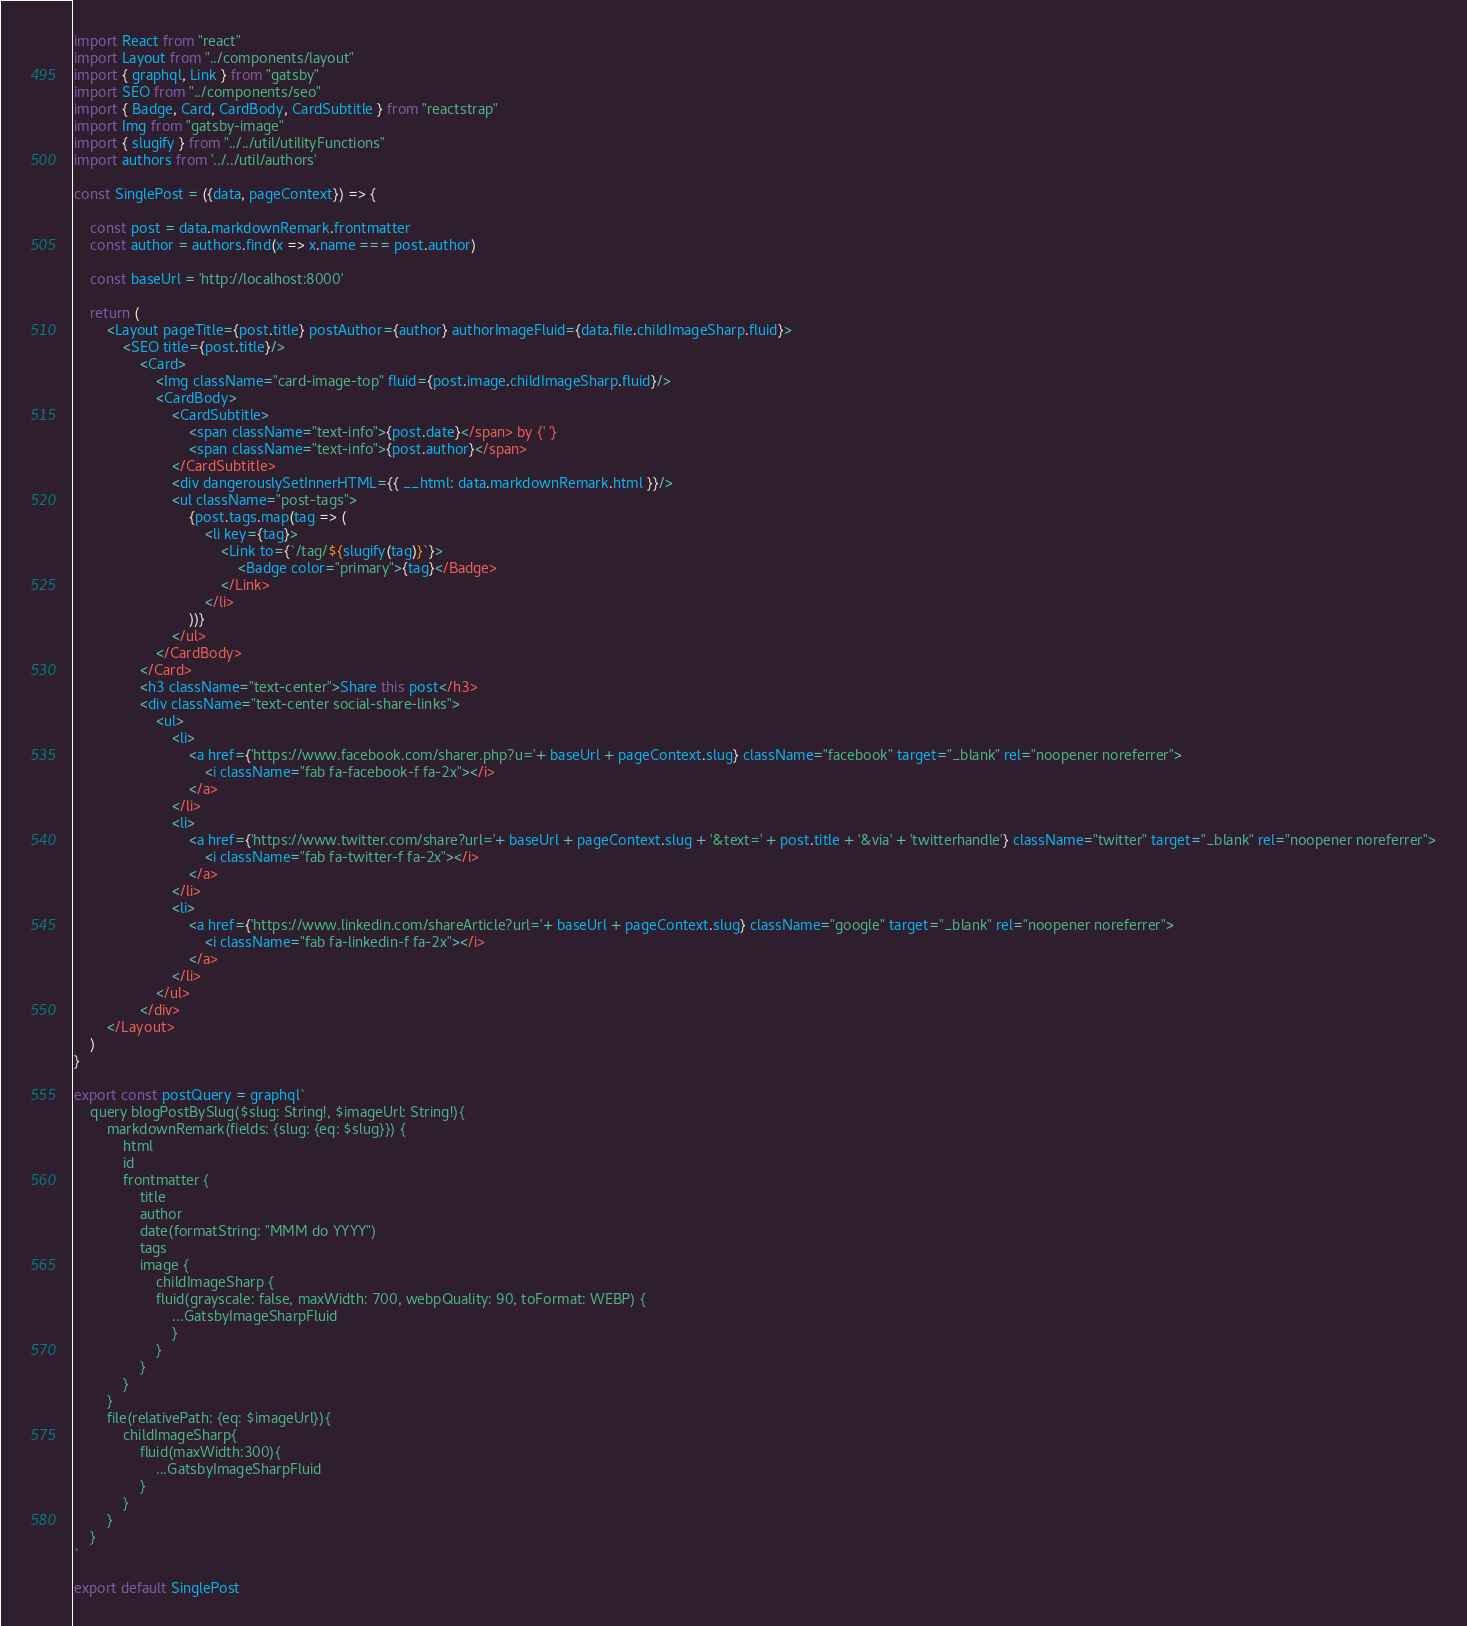Convert code to text. <code><loc_0><loc_0><loc_500><loc_500><_JavaScript_>import React from "react"
import Layout from "../components/layout"
import { graphql, Link } from "gatsby"
import SEO from "../components/seo"
import { Badge, Card, CardBody, CardSubtitle } from "reactstrap"
import Img from "gatsby-image"
import { slugify } from "../../util/utilityFunctions"
import authors from '../../util/authors'

const SinglePost = ({data, pageContext}) => {

    const post = data.markdownRemark.frontmatter
    const author = authors.find(x => x.name === post.author)

    const baseUrl = 'http://localhost:8000'

    return (
        <Layout pageTitle={post.title} postAuthor={author} authorImageFluid={data.file.childImageSharp.fluid}>
            <SEO title={post.title}/>
                <Card>
                    <Img className="card-image-top" fluid={post.image.childImageSharp.fluid}/>
                    <CardBody>
                        <CardSubtitle>
                            <span className="text-info">{post.date}</span> by {' '}
                            <span className="text-info">{post.author}</span>
                        </CardSubtitle>
                        <div dangerouslySetInnerHTML={{ __html: data.markdownRemark.html }}/>
                        <ul className="post-tags">
                            {post.tags.map(tag => (
                                <li key={tag}>
                                    <Link to={`/tag/${slugify(tag)}`}>
                                        <Badge color="primary">{tag}</Badge>
                                    </Link>
                                </li>
                            ))}
                        </ul>
                    </CardBody>
                </Card>
                <h3 className="text-center">Share this post</h3>
                <div className="text-center social-share-links">
                    <ul>
                        <li>
                            <a href={'https://www.facebook.com/sharer.php?u='+ baseUrl + pageContext.slug} className="facebook" target="_blank" rel="noopener noreferrer">
                                <i className="fab fa-facebook-f fa-2x"></i>
                            </a>
                        </li>
                        <li>
                            <a href={'https://www.twitter.com/share?url='+ baseUrl + pageContext.slug + '&text=' + post.title + '&via' + 'twitterhandle'} className="twitter" target="_blank" rel="noopener noreferrer">
                                <i className="fab fa-twitter-f fa-2x"></i>
                            </a>
                        </li>
                        <li>
                            <a href={'https://www.linkedin.com/shareArticle?url='+ baseUrl + pageContext.slug} className="google" target="_blank" rel="noopener noreferrer">
                                <i className="fab fa-linkedin-f fa-2x"></i>
                            </a>
                        </li>
                    </ul>
                </div>
        </Layout>
    )
}

export const postQuery = graphql`
    query blogPostBySlug($slug: String!, $imageUrl: String!){
        markdownRemark(fields: {slug: {eq: $slug}}) {
            html
            id
            frontmatter {
                title
                author
                date(formatString: "MMM do YYYY")
                tags
                image {
                    childImageSharp {
                    fluid(grayscale: false, maxWidth: 700, webpQuality: 90, toFormat: WEBP) {
                        ...GatsbyImageSharpFluid
                        }
                    }
                }
            }
        }
        file(relativePath: {eq: $imageUrl}){
            childImageSharp{
                fluid(maxWidth:300){
                    ...GatsbyImageSharpFluid
                }
            }
        }
    }
`

export default SinglePost</code> 